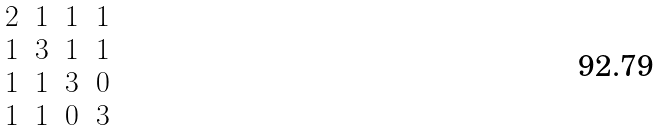<formula> <loc_0><loc_0><loc_500><loc_500>\begin{matrix} 2 & 1 & 1 & 1 \\ 1 & 3 & 1 & 1 \\ 1 & 1 & 3 & 0 \\ 1 & 1 & 0 & 3 \end{matrix}</formula> 